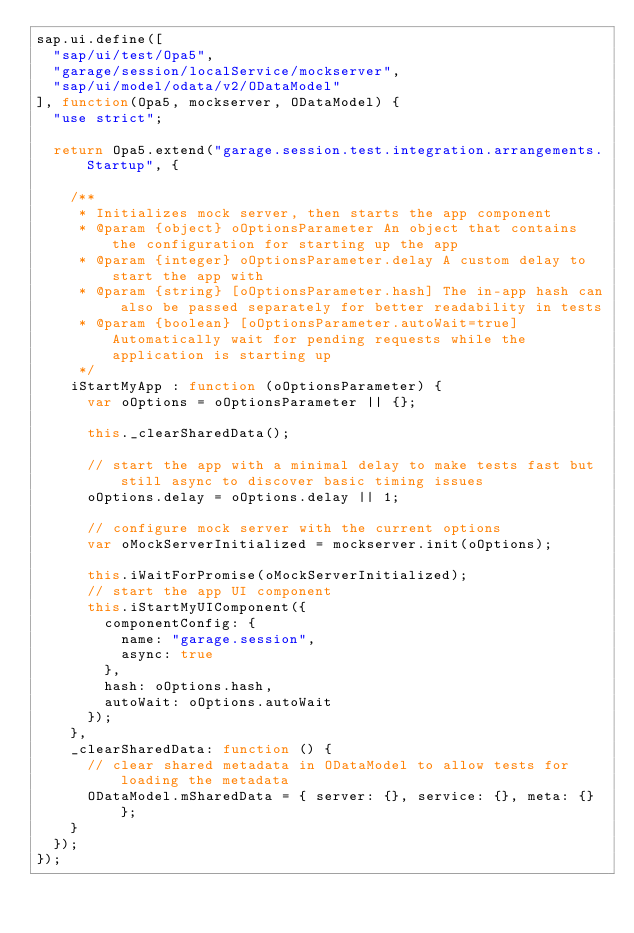Convert code to text. <code><loc_0><loc_0><loc_500><loc_500><_JavaScript_>sap.ui.define([
	"sap/ui/test/Opa5",
	"garage/session/localService/mockserver",
	"sap/ui/model/odata/v2/ODataModel"
], function(Opa5, mockserver, ODataModel) {
	"use strict";

	return Opa5.extend("garage.session.test.integration.arrangements.Startup", {

		/**
		 * Initializes mock server, then starts the app component
		 * @param {object} oOptionsParameter An object that contains the configuration for starting up the app
		 * @param {integer} oOptionsParameter.delay A custom delay to start the app with
		 * @param {string} [oOptionsParameter.hash] The in-app hash can also be passed separately for better readability in tests
		 * @param {boolean} [oOptionsParameter.autoWait=true] Automatically wait for pending requests while the application is starting up
		 */
		iStartMyApp : function (oOptionsParameter) {
			var oOptions = oOptionsParameter || {};

			this._clearSharedData();

			// start the app with a minimal delay to make tests fast but still async to discover basic timing issues
			oOptions.delay = oOptions.delay || 1;

			// configure mock server with the current options
			var oMockServerInitialized = mockserver.init(oOptions);

			this.iWaitForPromise(oMockServerInitialized);
			// start the app UI component
			this.iStartMyUIComponent({
				componentConfig: {
					name: "garage.session",
					async: true
				},
				hash: oOptions.hash,
				autoWait: oOptions.autoWait
			});
		},
		_clearSharedData: function () {
			// clear shared metadata in ODataModel to allow tests for loading the metadata
			ODataModel.mSharedData = { server: {}, service: {}, meta: {} };
		}
	});
});</code> 